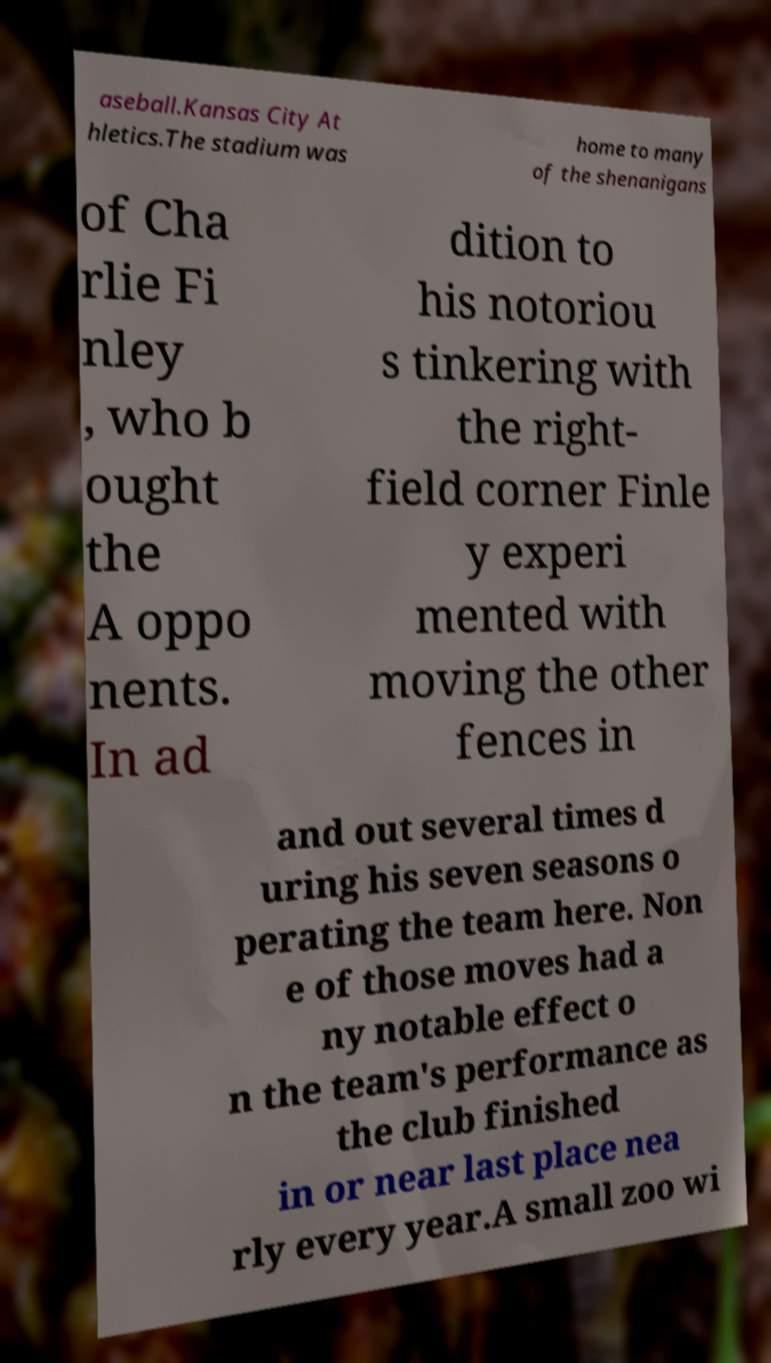Could you assist in decoding the text presented in this image and type it out clearly? aseball.Kansas City At hletics.The stadium was home to many of the shenanigans of Cha rlie Fi nley , who b ought the A oppo nents. In ad dition to his notoriou s tinkering with the right- field corner Finle y experi mented with moving the other fences in and out several times d uring his seven seasons o perating the team here. Non e of those moves had a ny notable effect o n the team's performance as the club finished in or near last place nea rly every year.A small zoo wi 